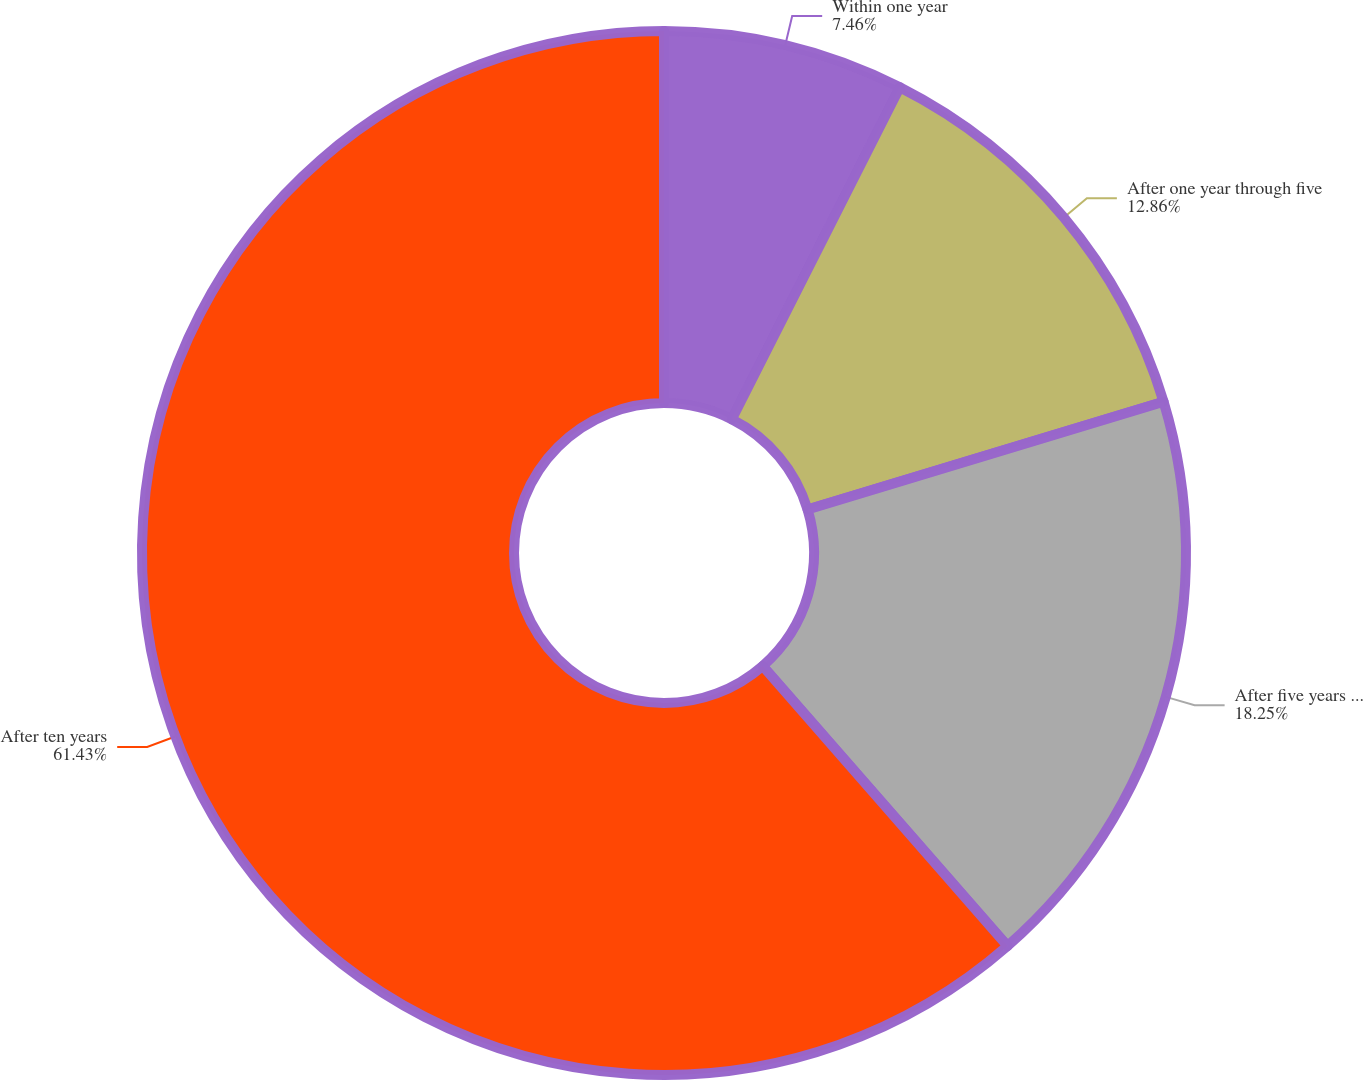Convert chart. <chart><loc_0><loc_0><loc_500><loc_500><pie_chart><fcel>Within one year<fcel>After one year through five<fcel>After five years through ten<fcel>After ten years<nl><fcel>7.46%<fcel>12.86%<fcel>18.25%<fcel>61.43%<nl></chart> 